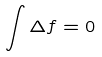<formula> <loc_0><loc_0><loc_500><loc_500>\int \Delta f = 0</formula> 